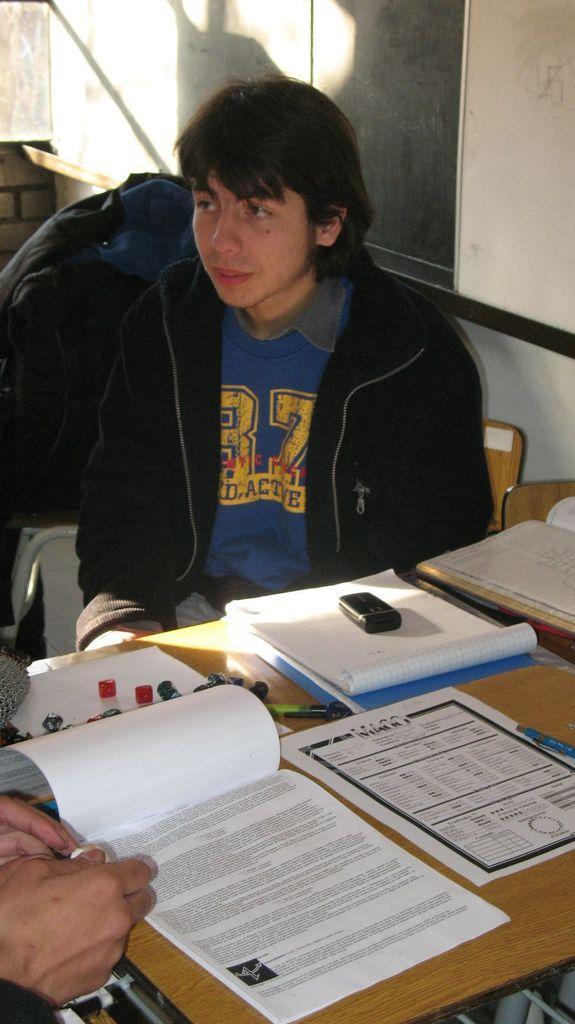In one or two sentences, can you explain what this image depicts? In this image there is a person sitting on the chair. In front of him there is a table. On top of it there are papers, books, mobile and a few other objects. On the left side of the image there is another person. In the background of the image there is a wall. 